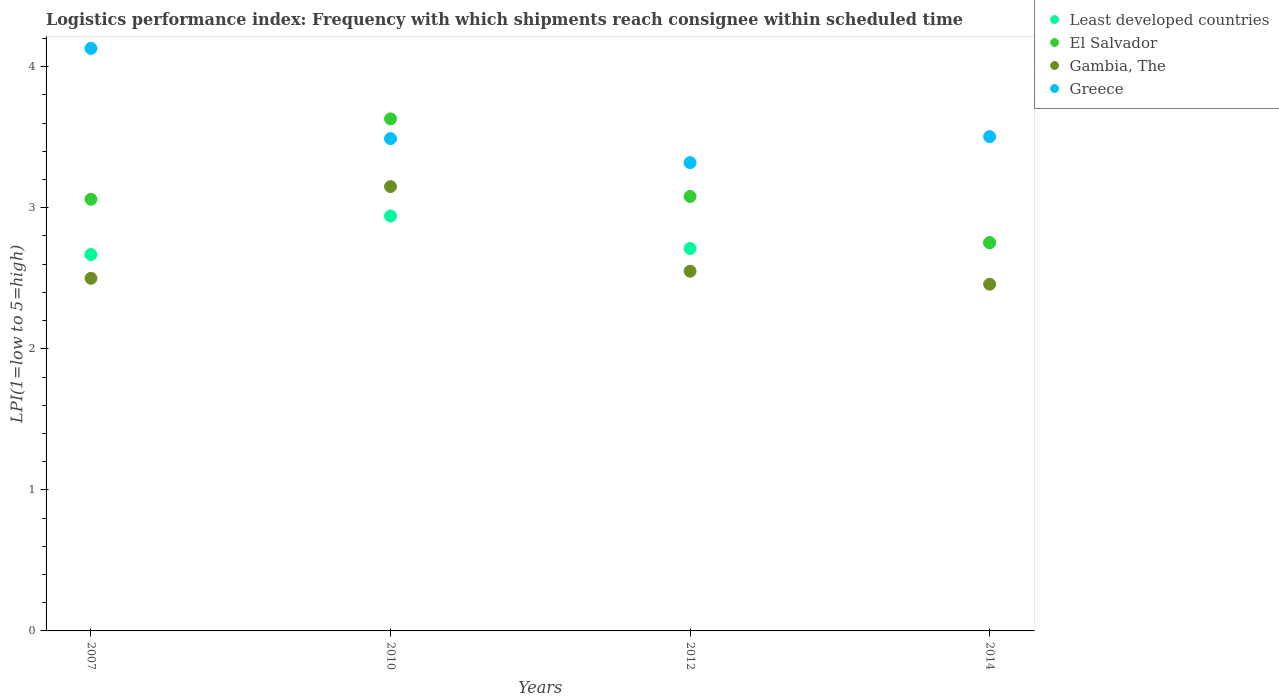How many different coloured dotlines are there?
Ensure brevity in your answer.  4. Is the number of dotlines equal to the number of legend labels?
Offer a terse response. Yes. Across all years, what is the maximum logistics performance index in Least developed countries?
Make the answer very short. 2.94. Across all years, what is the minimum logistics performance index in Gambia, The?
Your response must be concise. 2.46. What is the total logistics performance index in Gambia, The in the graph?
Your answer should be compact. 10.66. What is the difference between the logistics performance index in Greece in 2012 and that in 2014?
Provide a short and direct response. -0.18. What is the difference between the logistics performance index in Greece in 2010 and the logistics performance index in Gambia, The in 2012?
Provide a succinct answer. 0.94. What is the average logistics performance index in Greece per year?
Offer a very short reply. 3.61. In the year 2014, what is the difference between the logistics performance index in Least developed countries and logistics performance index in Gambia, The?
Your answer should be very brief. 0.29. In how many years, is the logistics performance index in Least developed countries greater than 1?
Ensure brevity in your answer.  4. What is the ratio of the logistics performance index in Gambia, The in 2007 to that in 2010?
Ensure brevity in your answer.  0.79. What is the difference between the highest and the second highest logistics performance index in Gambia, The?
Give a very brief answer. 0.6. What is the difference between the highest and the lowest logistics performance index in Greece?
Keep it short and to the point. 0.81. Is the sum of the logistics performance index in Greece in 2012 and 2014 greater than the maximum logistics performance index in Least developed countries across all years?
Keep it short and to the point. Yes. Is it the case that in every year, the sum of the logistics performance index in Gambia, The and logistics performance index in El Salvador  is greater than the sum of logistics performance index in Greece and logistics performance index in Least developed countries?
Provide a short and direct response. No. Does the logistics performance index in Greece monotonically increase over the years?
Provide a short and direct response. No. Is the logistics performance index in Gambia, The strictly greater than the logistics performance index in Least developed countries over the years?
Give a very brief answer. No. How many years are there in the graph?
Ensure brevity in your answer.  4. Does the graph contain grids?
Your answer should be compact. No. Where does the legend appear in the graph?
Ensure brevity in your answer.  Top right. How are the legend labels stacked?
Provide a succinct answer. Vertical. What is the title of the graph?
Your answer should be very brief. Logistics performance index: Frequency with which shipments reach consignee within scheduled time. Does "American Samoa" appear as one of the legend labels in the graph?
Give a very brief answer. No. What is the label or title of the X-axis?
Give a very brief answer. Years. What is the label or title of the Y-axis?
Provide a short and direct response. LPI(1=low to 5=high). What is the LPI(1=low to 5=high) in Least developed countries in 2007?
Your answer should be very brief. 2.67. What is the LPI(1=low to 5=high) of El Salvador in 2007?
Give a very brief answer. 3.06. What is the LPI(1=low to 5=high) in Gambia, The in 2007?
Your answer should be very brief. 2.5. What is the LPI(1=low to 5=high) in Greece in 2007?
Provide a succinct answer. 4.13. What is the LPI(1=low to 5=high) in Least developed countries in 2010?
Your answer should be compact. 2.94. What is the LPI(1=low to 5=high) in El Salvador in 2010?
Give a very brief answer. 3.63. What is the LPI(1=low to 5=high) of Gambia, The in 2010?
Provide a succinct answer. 3.15. What is the LPI(1=low to 5=high) in Greece in 2010?
Provide a succinct answer. 3.49. What is the LPI(1=low to 5=high) in Least developed countries in 2012?
Ensure brevity in your answer.  2.71. What is the LPI(1=low to 5=high) of El Salvador in 2012?
Your answer should be very brief. 3.08. What is the LPI(1=low to 5=high) in Gambia, The in 2012?
Your answer should be compact. 2.55. What is the LPI(1=low to 5=high) of Greece in 2012?
Provide a succinct answer. 3.32. What is the LPI(1=low to 5=high) of Least developed countries in 2014?
Keep it short and to the point. 2.75. What is the LPI(1=low to 5=high) in El Salvador in 2014?
Make the answer very short. 2.75. What is the LPI(1=low to 5=high) in Gambia, The in 2014?
Offer a very short reply. 2.46. What is the LPI(1=low to 5=high) in Greece in 2014?
Provide a succinct answer. 3.5. Across all years, what is the maximum LPI(1=low to 5=high) in Least developed countries?
Your response must be concise. 2.94. Across all years, what is the maximum LPI(1=low to 5=high) in El Salvador?
Ensure brevity in your answer.  3.63. Across all years, what is the maximum LPI(1=low to 5=high) in Gambia, The?
Keep it short and to the point. 3.15. Across all years, what is the maximum LPI(1=low to 5=high) of Greece?
Make the answer very short. 4.13. Across all years, what is the minimum LPI(1=low to 5=high) of Least developed countries?
Provide a short and direct response. 2.67. Across all years, what is the minimum LPI(1=low to 5=high) of El Salvador?
Offer a terse response. 2.75. Across all years, what is the minimum LPI(1=low to 5=high) of Gambia, The?
Your response must be concise. 2.46. Across all years, what is the minimum LPI(1=low to 5=high) of Greece?
Provide a short and direct response. 3.32. What is the total LPI(1=low to 5=high) in Least developed countries in the graph?
Provide a short and direct response. 11.07. What is the total LPI(1=low to 5=high) of El Salvador in the graph?
Your response must be concise. 12.52. What is the total LPI(1=low to 5=high) in Gambia, The in the graph?
Offer a terse response. 10.66. What is the total LPI(1=low to 5=high) of Greece in the graph?
Offer a terse response. 14.44. What is the difference between the LPI(1=low to 5=high) of Least developed countries in 2007 and that in 2010?
Ensure brevity in your answer.  -0.27. What is the difference between the LPI(1=low to 5=high) in El Salvador in 2007 and that in 2010?
Keep it short and to the point. -0.57. What is the difference between the LPI(1=low to 5=high) in Gambia, The in 2007 and that in 2010?
Keep it short and to the point. -0.65. What is the difference between the LPI(1=low to 5=high) in Greece in 2007 and that in 2010?
Offer a terse response. 0.64. What is the difference between the LPI(1=low to 5=high) of Least developed countries in 2007 and that in 2012?
Your response must be concise. -0.04. What is the difference between the LPI(1=low to 5=high) of El Salvador in 2007 and that in 2012?
Your answer should be very brief. -0.02. What is the difference between the LPI(1=low to 5=high) in Greece in 2007 and that in 2012?
Make the answer very short. 0.81. What is the difference between the LPI(1=low to 5=high) in Least developed countries in 2007 and that in 2014?
Keep it short and to the point. -0.08. What is the difference between the LPI(1=low to 5=high) of El Salvador in 2007 and that in 2014?
Give a very brief answer. 0.31. What is the difference between the LPI(1=low to 5=high) of Gambia, The in 2007 and that in 2014?
Your answer should be very brief. 0.04. What is the difference between the LPI(1=low to 5=high) of Greece in 2007 and that in 2014?
Provide a short and direct response. 0.63. What is the difference between the LPI(1=low to 5=high) in Least developed countries in 2010 and that in 2012?
Make the answer very short. 0.23. What is the difference between the LPI(1=low to 5=high) in El Salvador in 2010 and that in 2012?
Your response must be concise. 0.55. What is the difference between the LPI(1=low to 5=high) in Gambia, The in 2010 and that in 2012?
Make the answer very short. 0.6. What is the difference between the LPI(1=low to 5=high) in Greece in 2010 and that in 2012?
Keep it short and to the point. 0.17. What is the difference between the LPI(1=low to 5=high) in Least developed countries in 2010 and that in 2014?
Provide a short and direct response. 0.19. What is the difference between the LPI(1=low to 5=high) in El Salvador in 2010 and that in 2014?
Provide a succinct answer. 0.88. What is the difference between the LPI(1=low to 5=high) in Gambia, The in 2010 and that in 2014?
Offer a very short reply. 0.69. What is the difference between the LPI(1=low to 5=high) in Greece in 2010 and that in 2014?
Make the answer very short. -0.01. What is the difference between the LPI(1=low to 5=high) in Least developed countries in 2012 and that in 2014?
Your response must be concise. -0.04. What is the difference between the LPI(1=low to 5=high) in El Salvador in 2012 and that in 2014?
Offer a very short reply. 0.33. What is the difference between the LPI(1=low to 5=high) in Gambia, The in 2012 and that in 2014?
Provide a succinct answer. 0.09. What is the difference between the LPI(1=low to 5=high) of Greece in 2012 and that in 2014?
Ensure brevity in your answer.  -0.18. What is the difference between the LPI(1=low to 5=high) of Least developed countries in 2007 and the LPI(1=low to 5=high) of El Salvador in 2010?
Ensure brevity in your answer.  -0.96. What is the difference between the LPI(1=low to 5=high) of Least developed countries in 2007 and the LPI(1=low to 5=high) of Gambia, The in 2010?
Provide a succinct answer. -0.48. What is the difference between the LPI(1=low to 5=high) of Least developed countries in 2007 and the LPI(1=low to 5=high) of Greece in 2010?
Offer a terse response. -0.82. What is the difference between the LPI(1=low to 5=high) in El Salvador in 2007 and the LPI(1=low to 5=high) in Gambia, The in 2010?
Make the answer very short. -0.09. What is the difference between the LPI(1=low to 5=high) in El Salvador in 2007 and the LPI(1=low to 5=high) in Greece in 2010?
Your response must be concise. -0.43. What is the difference between the LPI(1=low to 5=high) of Gambia, The in 2007 and the LPI(1=low to 5=high) of Greece in 2010?
Your answer should be compact. -0.99. What is the difference between the LPI(1=low to 5=high) of Least developed countries in 2007 and the LPI(1=low to 5=high) of El Salvador in 2012?
Give a very brief answer. -0.41. What is the difference between the LPI(1=low to 5=high) of Least developed countries in 2007 and the LPI(1=low to 5=high) of Gambia, The in 2012?
Offer a terse response. 0.12. What is the difference between the LPI(1=low to 5=high) of Least developed countries in 2007 and the LPI(1=low to 5=high) of Greece in 2012?
Your answer should be very brief. -0.65. What is the difference between the LPI(1=low to 5=high) of El Salvador in 2007 and the LPI(1=low to 5=high) of Gambia, The in 2012?
Keep it short and to the point. 0.51. What is the difference between the LPI(1=low to 5=high) of El Salvador in 2007 and the LPI(1=low to 5=high) of Greece in 2012?
Your response must be concise. -0.26. What is the difference between the LPI(1=low to 5=high) in Gambia, The in 2007 and the LPI(1=low to 5=high) in Greece in 2012?
Make the answer very short. -0.82. What is the difference between the LPI(1=low to 5=high) in Least developed countries in 2007 and the LPI(1=low to 5=high) in El Salvador in 2014?
Your answer should be very brief. -0.08. What is the difference between the LPI(1=low to 5=high) of Least developed countries in 2007 and the LPI(1=low to 5=high) of Gambia, The in 2014?
Your answer should be very brief. 0.21. What is the difference between the LPI(1=low to 5=high) in Least developed countries in 2007 and the LPI(1=low to 5=high) in Greece in 2014?
Offer a very short reply. -0.84. What is the difference between the LPI(1=low to 5=high) of El Salvador in 2007 and the LPI(1=low to 5=high) of Gambia, The in 2014?
Your answer should be compact. 0.6. What is the difference between the LPI(1=low to 5=high) in El Salvador in 2007 and the LPI(1=low to 5=high) in Greece in 2014?
Your answer should be very brief. -0.44. What is the difference between the LPI(1=low to 5=high) in Gambia, The in 2007 and the LPI(1=low to 5=high) in Greece in 2014?
Ensure brevity in your answer.  -1. What is the difference between the LPI(1=low to 5=high) in Least developed countries in 2010 and the LPI(1=low to 5=high) in El Salvador in 2012?
Your response must be concise. -0.14. What is the difference between the LPI(1=low to 5=high) in Least developed countries in 2010 and the LPI(1=low to 5=high) in Gambia, The in 2012?
Your answer should be very brief. 0.39. What is the difference between the LPI(1=low to 5=high) of Least developed countries in 2010 and the LPI(1=low to 5=high) of Greece in 2012?
Your answer should be very brief. -0.38. What is the difference between the LPI(1=low to 5=high) in El Salvador in 2010 and the LPI(1=low to 5=high) in Greece in 2012?
Offer a very short reply. 0.31. What is the difference between the LPI(1=low to 5=high) in Gambia, The in 2010 and the LPI(1=low to 5=high) in Greece in 2012?
Your answer should be very brief. -0.17. What is the difference between the LPI(1=low to 5=high) of Least developed countries in 2010 and the LPI(1=low to 5=high) of El Salvador in 2014?
Your answer should be compact. 0.19. What is the difference between the LPI(1=low to 5=high) of Least developed countries in 2010 and the LPI(1=low to 5=high) of Gambia, The in 2014?
Make the answer very short. 0.48. What is the difference between the LPI(1=low to 5=high) in Least developed countries in 2010 and the LPI(1=low to 5=high) in Greece in 2014?
Offer a very short reply. -0.56. What is the difference between the LPI(1=low to 5=high) in El Salvador in 2010 and the LPI(1=low to 5=high) in Gambia, The in 2014?
Your answer should be compact. 1.17. What is the difference between the LPI(1=low to 5=high) of El Salvador in 2010 and the LPI(1=low to 5=high) of Greece in 2014?
Keep it short and to the point. 0.13. What is the difference between the LPI(1=low to 5=high) of Gambia, The in 2010 and the LPI(1=low to 5=high) of Greece in 2014?
Provide a short and direct response. -0.35. What is the difference between the LPI(1=low to 5=high) of Least developed countries in 2012 and the LPI(1=low to 5=high) of El Salvador in 2014?
Ensure brevity in your answer.  -0.04. What is the difference between the LPI(1=low to 5=high) in Least developed countries in 2012 and the LPI(1=low to 5=high) in Gambia, The in 2014?
Your answer should be very brief. 0.25. What is the difference between the LPI(1=low to 5=high) of Least developed countries in 2012 and the LPI(1=low to 5=high) of Greece in 2014?
Provide a succinct answer. -0.79. What is the difference between the LPI(1=low to 5=high) of El Salvador in 2012 and the LPI(1=low to 5=high) of Gambia, The in 2014?
Give a very brief answer. 0.62. What is the difference between the LPI(1=low to 5=high) in El Salvador in 2012 and the LPI(1=low to 5=high) in Greece in 2014?
Keep it short and to the point. -0.42. What is the difference between the LPI(1=low to 5=high) in Gambia, The in 2012 and the LPI(1=low to 5=high) in Greece in 2014?
Ensure brevity in your answer.  -0.95. What is the average LPI(1=low to 5=high) in Least developed countries per year?
Your response must be concise. 2.77. What is the average LPI(1=low to 5=high) in El Salvador per year?
Provide a succinct answer. 3.13. What is the average LPI(1=low to 5=high) in Gambia, The per year?
Your response must be concise. 2.66. What is the average LPI(1=low to 5=high) in Greece per year?
Make the answer very short. 3.61. In the year 2007, what is the difference between the LPI(1=low to 5=high) in Least developed countries and LPI(1=low to 5=high) in El Salvador?
Make the answer very short. -0.39. In the year 2007, what is the difference between the LPI(1=low to 5=high) of Least developed countries and LPI(1=low to 5=high) of Gambia, The?
Offer a terse response. 0.17. In the year 2007, what is the difference between the LPI(1=low to 5=high) of Least developed countries and LPI(1=low to 5=high) of Greece?
Make the answer very short. -1.46. In the year 2007, what is the difference between the LPI(1=low to 5=high) of El Salvador and LPI(1=low to 5=high) of Gambia, The?
Keep it short and to the point. 0.56. In the year 2007, what is the difference between the LPI(1=low to 5=high) of El Salvador and LPI(1=low to 5=high) of Greece?
Ensure brevity in your answer.  -1.07. In the year 2007, what is the difference between the LPI(1=low to 5=high) of Gambia, The and LPI(1=low to 5=high) of Greece?
Your answer should be compact. -1.63. In the year 2010, what is the difference between the LPI(1=low to 5=high) of Least developed countries and LPI(1=low to 5=high) of El Salvador?
Ensure brevity in your answer.  -0.69. In the year 2010, what is the difference between the LPI(1=low to 5=high) of Least developed countries and LPI(1=low to 5=high) of Gambia, The?
Provide a short and direct response. -0.21. In the year 2010, what is the difference between the LPI(1=low to 5=high) in Least developed countries and LPI(1=low to 5=high) in Greece?
Your answer should be very brief. -0.55. In the year 2010, what is the difference between the LPI(1=low to 5=high) in El Salvador and LPI(1=low to 5=high) in Gambia, The?
Make the answer very short. 0.48. In the year 2010, what is the difference between the LPI(1=low to 5=high) of El Salvador and LPI(1=low to 5=high) of Greece?
Your response must be concise. 0.14. In the year 2010, what is the difference between the LPI(1=low to 5=high) of Gambia, The and LPI(1=low to 5=high) of Greece?
Provide a succinct answer. -0.34. In the year 2012, what is the difference between the LPI(1=low to 5=high) of Least developed countries and LPI(1=low to 5=high) of El Salvador?
Your answer should be very brief. -0.37. In the year 2012, what is the difference between the LPI(1=low to 5=high) in Least developed countries and LPI(1=low to 5=high) in Gambia, The?
Your answer should be compact. 0.16. In the year 2012, what is the difference between the LPI(1=low to 5=high) of Least developed countries and LPI(1=low to 5=high) of Greece?
Give a very brief answer. -0.61. In the year 2012, what is the difference between the LPI(1=low to 5=high) in El Salvador and LPI(1=low to 5=high) in Gambia, The?
Your answer should be very brief. 0.53. In the year 2012, what is the difference between the LPI(1=low to 5=high) in El Salvador and LPI(1=low to 5=high) in Greece?
Provide a succinct answer. -0.24. In the year 2012, what is the difference between the LPI(1=low to 5=high) in Gambia, The and LPI(1=low to 5=high) in Greece?
Offer a very short reply. -0.77. In the year 2014, what is the difference between the LPI(1=low to 5=high) of Least developed countries and LPI(1=low to 5=high) of El Salvador?
Keep it short and to the point. -0. In the year 2014, what is the difference between the LPI(1=low to 5=high) of Least developed countries and LPI(1=low to 5=high) of Gambia, The?
Offer a very short reply. 0.29. In the year 2014, what is the difference between the LPI(1=low to 5=high) of Least developed countries and LPI(1=low to 5=high) of Greece?
Provide a succinct answer. -0.75. In the year 2014, what is the difference between the LPI(1=low to 5=high) in El Salvador and LPI(1=low to 5=high) in Gambia, The?
Offer a very short reply. 0.3. In the year 2014, what is the difference between the LPI(1=low to 5=high) of El Salvador and LPI(1=low to 5=high) of Greece?
Offer a terse response. -0.75. In the year 2014, what is the difference between the LPI(1=low to 5=high) of Gambia, The and LPI(1=low to 5=high) of Greece?
Your answer should be very brief. -1.05. What is the ratio of the LPI(1=low to 5=high) of Least developed countries in 2007 to that in 2010?
Your response must be concise. 0.91. What is the ratio of the LPI(1=low to 5=high) in El Salvador in 2007 to that in 2010?
Your response must be concise. 0.84. What is the ratio of the LPI(1=low to 5=high) in Gambia, The in 2007 to that in 2010?
Give a very brief answer. 0.79. What is the ratio of the LPI(1=low to 5=high) in Greece in 2007 to that in 2010?
Your response must be concise. 1.18. What is the ratio of the LPI(1=low to 5=high) of Least developed countries in 2007 to that in 2012?
Offer a terse response. 0.98. What is the ratio of the LPI(1=low to 5=high) in Gambia, The in 2007 to that in 2012?
Your response must be concise. 0.98. What is the ratio of the LPI(1=low to 5=high) in Greece in 2007 to that in 2012?
Make the answer very short. 1.24. What is the ratio of the LPI(1=low to 5=high) in Least developed countries in 2007 to that in 2014?
Your answer should be compact. 0.97. What is the ratio of the LPI(1=low to 5=high) in El Salvador in 2007 to that in 2014?
Make the answer very short. 1.11. What is the ratio of the LPI(1=low to 5=high) in Gambia, The in 2007 to that in 2014?
Your answer should be very brief. 1.02. What is the ratio of the LPI(1=low to 5=high) in Greece in 2007 to that in 2014?
Provide a succinct answer. 1.18. What is the ratio of the LPI(1=low to 5=high) in Least developed countries in 2010 to that in 2012?
Provide a short and direct response. 1.08. What is the ratio of the LPI(1=low to 5=high) of El Salvador in 2010 to that in 2012?
Make the answer very short. 1.18. What is the ratio of the LPI(1=low to 5=high) in Gambia, The in 2010 to that in 2012?
Give a very brief answer. 1.24. What is the ratio of the LPI(1=low to 5=high) in Greece in 2010 to that in 2012?
Keep it short and to the point. 1.05. What is the ratio of the LPI(1=low to 5=high) in Least developed countries in 2010 to that in 2014?
Keep it short and to the point. 1.07. What is the ratio of the LPI(1=low to 5=high) in El Salvador in 2010 to that in 2014?
Provide a succinct answer. 1.32. What is the ratio of the LPI(1=low to 5=high) in Gambia, The in 2010 to that in 2014?
Your response must be concise. 1.28. What is the ratio of the LPI(1=low to 5=high) of Greece in 2010 to that in 2014?
Your answer should be very brief. 1. What is the ratio of the LPI(1=low to 5=high) of Least developed countries in 2012 to that in 2014?
Keep it short and to the point. 0.99. What is the ratio of the LPI(1=low to 5=high) of El Salvador in 2012 to that in 2014?
Ensure brevity in your answer.  1.12. What is the ratio of the LPI(1=low to 5=high) of Gambia, The in 2012 to that in 2014?
Provide a succinct answer. 1.04. What is the ratio of the LPI(1=low to 5=high) in Greece in 2012 to that in 2014?
Make the answer very short. 0.95. What is the difference between the highest and the second highest LPI(1=low to 5=high) in Least developed countries?
Provide a short and direct response. 0.19. What is the difference between the highest and the second highest LPI(1=low to 5=high) in El Salvador?
Your answer should be very brief. 0.55. What is the difference between the highest and the second highest LPI(1=low to 5=high) in Gambia, The?
Keep it short and to the point. 0.6. What is the difference between the highest and the second highest LPI(1=low to 5=high) in Greece?
Provide a succinct answer. 0.63. What is the difference between the highest and the lowest LPI(1=low to 5=high) of Least developed countries?
Provide a succinct answer. 0.27. What is the difference between the highest and the lowest LPI(1=low to 5=high) of El Salvador?
Your answer should be compact. 0.88. What is the difference between the highest and the lowest LPI(1=low to 5=high) in Gambia, The?
Ensure brevity in your answer.  0.69. What is the difference between the highest and the lowest LPI(1=low to 5=high) of Greece?
Provide a short and direct response. 0.81. 